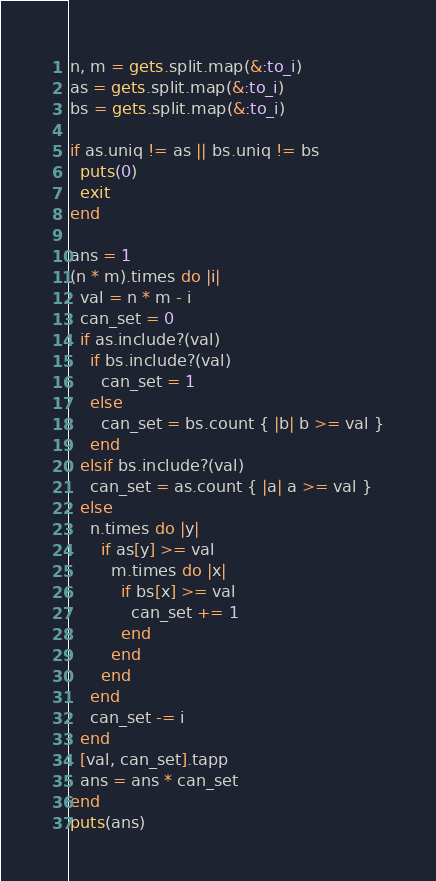<code> <loc_0><loc_0><loc_500><loc_500><_Ruby_>n, m = gets.split.map(&:to_i)
as = gets.split.map(&:to_i)
bs = gets.split.map(&:to_i)

if as.uniq != as || bs.uniq != bs
  puts(0)
  exit
end

ans = 1
(n * m).times do |i|
  val = n * m - i
  can_set = 0
  if as.include?(val)
    if bs.include?(val)
      can_set = 1
    else
      can_set = bs.count { |b| b >= val }
    end
  elsif bs.include?(val)
    can_set = as.count { |a| a >= val }
  else
    n.times do |y|
      if as[y] >= val
        m.times do |x|
          if bs[x] >= val
            can_set += 1
          end
        end
      end
    end
    can_set -= i
  end
  [val, can_set].tapp
  ans = ans * can_set
end
puts(ans)
</code> 